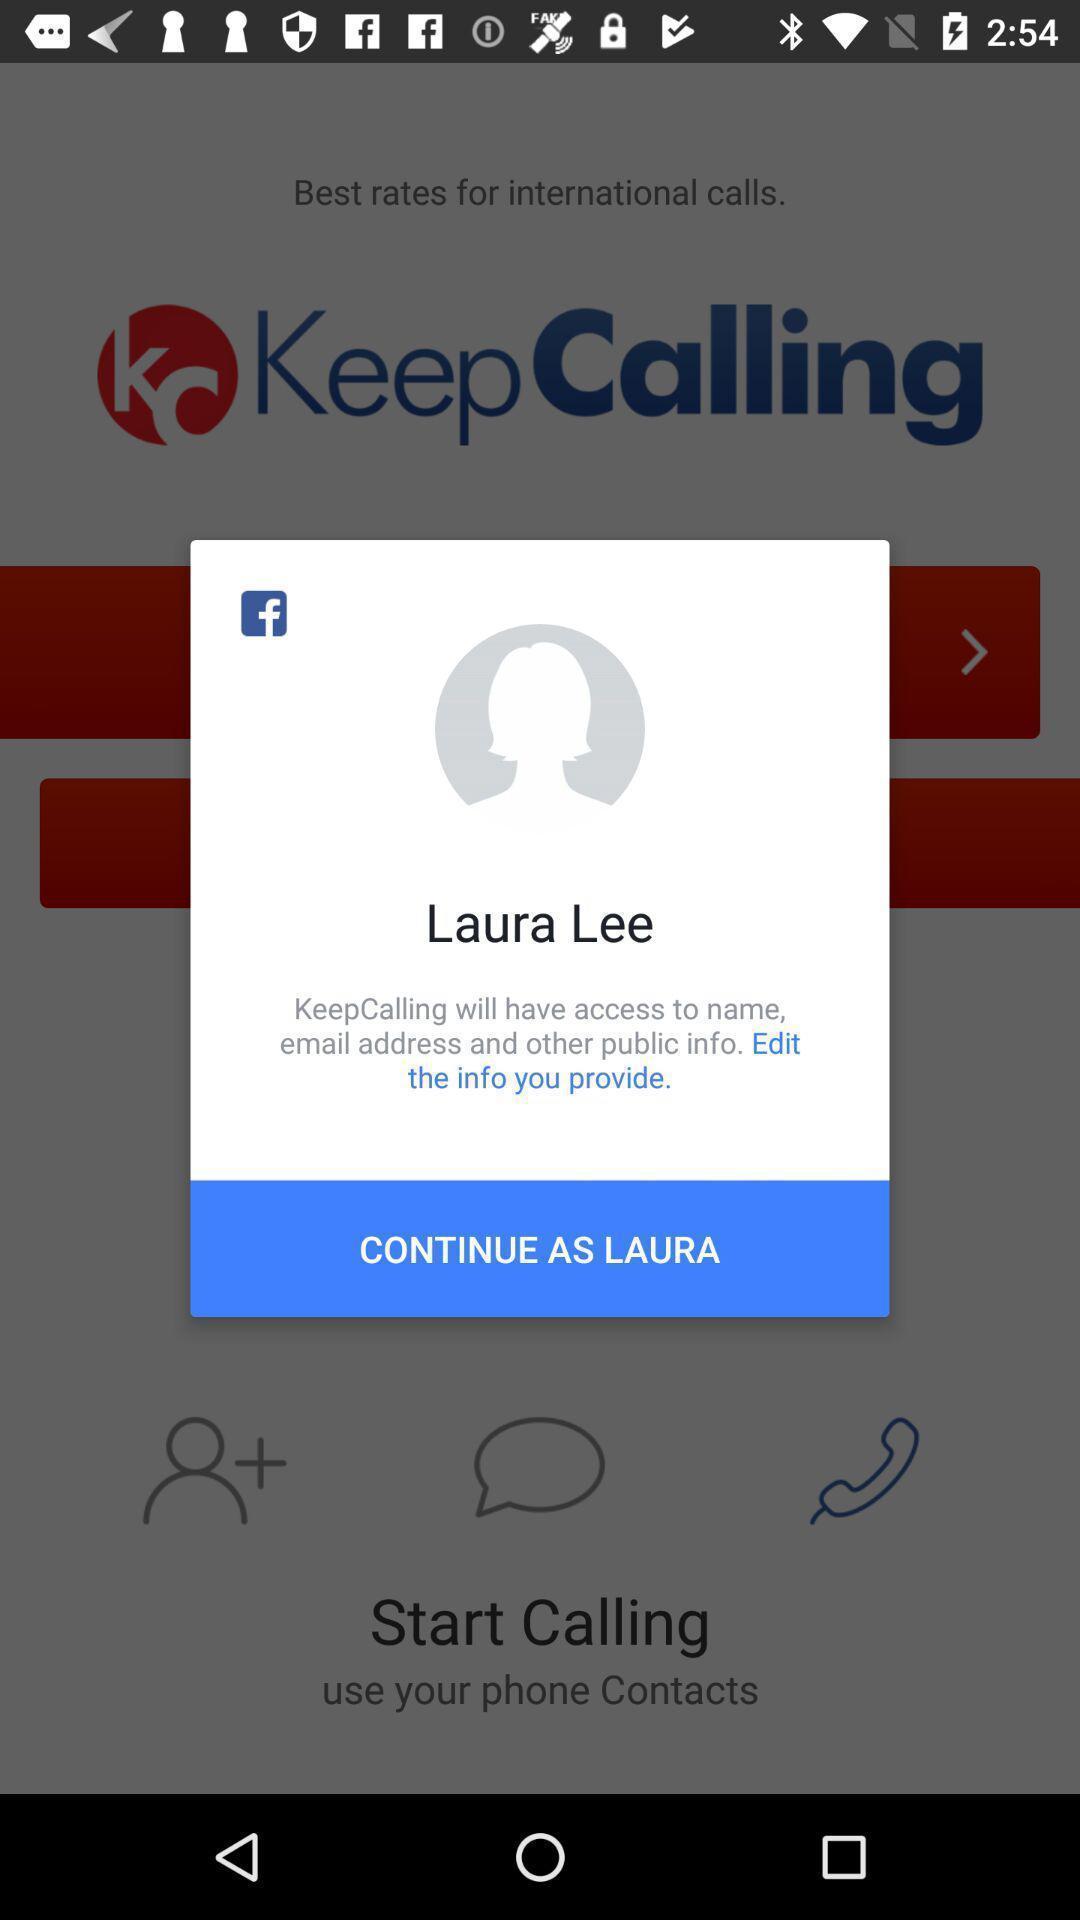Describe this image in words. Pop up profile page displayed. 